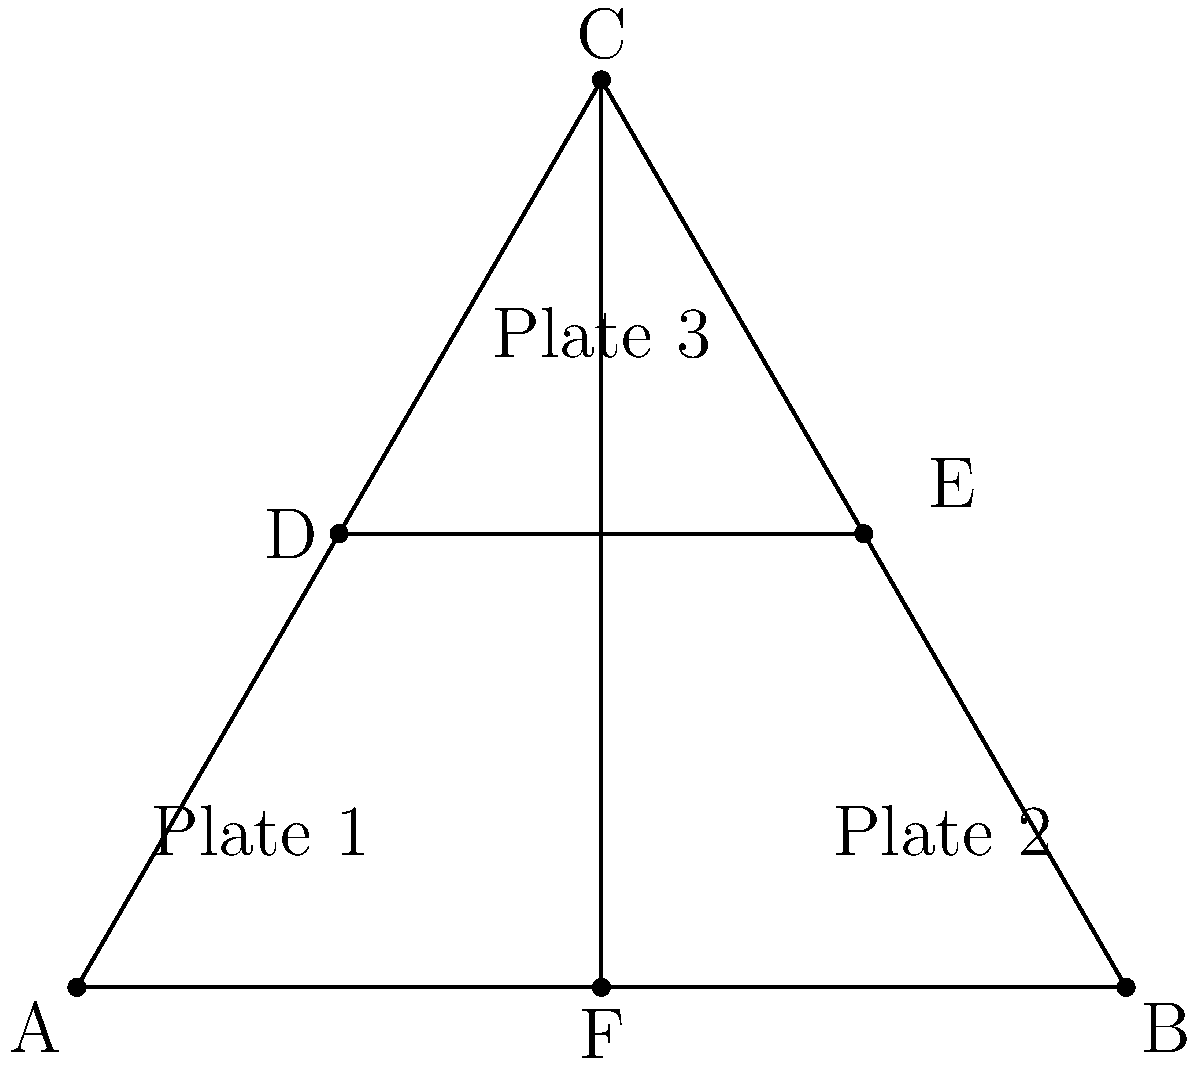In your latest blog post about geometric table settings, you've arranged three plates in an equilateral triangle formation with additional elements. If the distance between plates 1 and 2 is 6 units, what is the area of the triangle formed by the centers of the three plates? Let's approach this step-by-step:

1) First, we need to recognize that the plates form an equilateral triangle. This means all sides are equal and all angles are 60°.

2) We're given that the distance between plates 1 and 2 is 6 units. This forms the base of our equilateral triangle.

3) To find the area of an equilateral triangle, we can use the formula:

   $$A = \frac{\sqrt{3}}{4}a^2$$

   Where $a$ is the length of a side.

4) We know $a = 6$, so let's plug this into our formula:

   $$A = \frac{\sqrt{3}}{4}(6)^2$$

5) Simplify:
   $$A = \frac{\sqrt{3}}{4}(36)$$
   $$A = 9\sqrt{3}$$

6) Therefore, the area of the triangle formed by the centers of the three plates is $9\sqrt{3}$ square units.
Answer: $9\sqrt{3}$ square units 